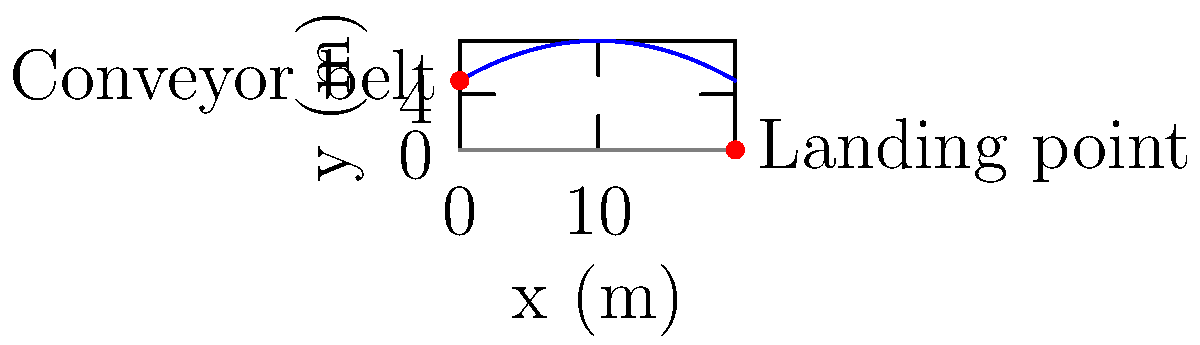A small object is launched from a conveyor belt in the factory at a height of 5 meters above the ground. It is projected with an initial velocity of 15 m/s at an angle of 30° above the horizontal. Assuming no air resistance, what is the horizontal distance traveled by the object before it hits the ground? Let's approach this step-by-step:

1) We'll use the equations of motion for projectile motion:
   $$x = v_0 \cos(\theta) t$$
   $$y = h_0 + v_0 \sin(\theta) t - \frac{1}{2}gt^2$$

   Where:
   $x$ is horizontal distance
   $y$ is vertical distance
   $v_0$ is initial velocity
   $\theta$ is launch angle
   $h_0$ is initial height
   $g$ is acceleration due to gravity (9.8 m/s²)
   $t$ is time

2) We want to find $x$ when $y = 0$ (ground level). So, we first need to find $t$ when $y = 0$:

   $$0 = 5 + 15 \sin(30°) t - \frac{1}{2}(9.8)t^2$$

3) Simplify:
   $$0 = 5 + 7.5t - 4.9t^2$$

4) This is a quadratic equation. We can solve it using the quadratic formula:
   $$t = \frac{-b \pm \sqrt{b^2 - 4ac}}{2a}$$

   Where $a = -4.9$, $b = 7.5$, and $c = 5$

5) Solving this gives us two values for $t$. We want the positive one:
   $$t \approx 1.81 \text{ seconds}$$

6) Now we can use this time in the equation for $x$:
   $$x = 15 \cos(30°) (1.81)$$

7) Simplify:
   $$x = 15 (0.866) (1.81) \approx 23.5 \text{ meters}$$
Answer: 23.5 meters 